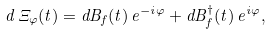Convert formula to latex. <formula><loc_0><loc_0><loc_500><loc_500>d \, \Xi _ { \varphi } ( t ) = d B _ { f } ( t ) \, e ^ { - i \varphi } + d B _ { f } ^ { \dagger } ( t ) \, e ^ { i \varphi } ,</formula> 